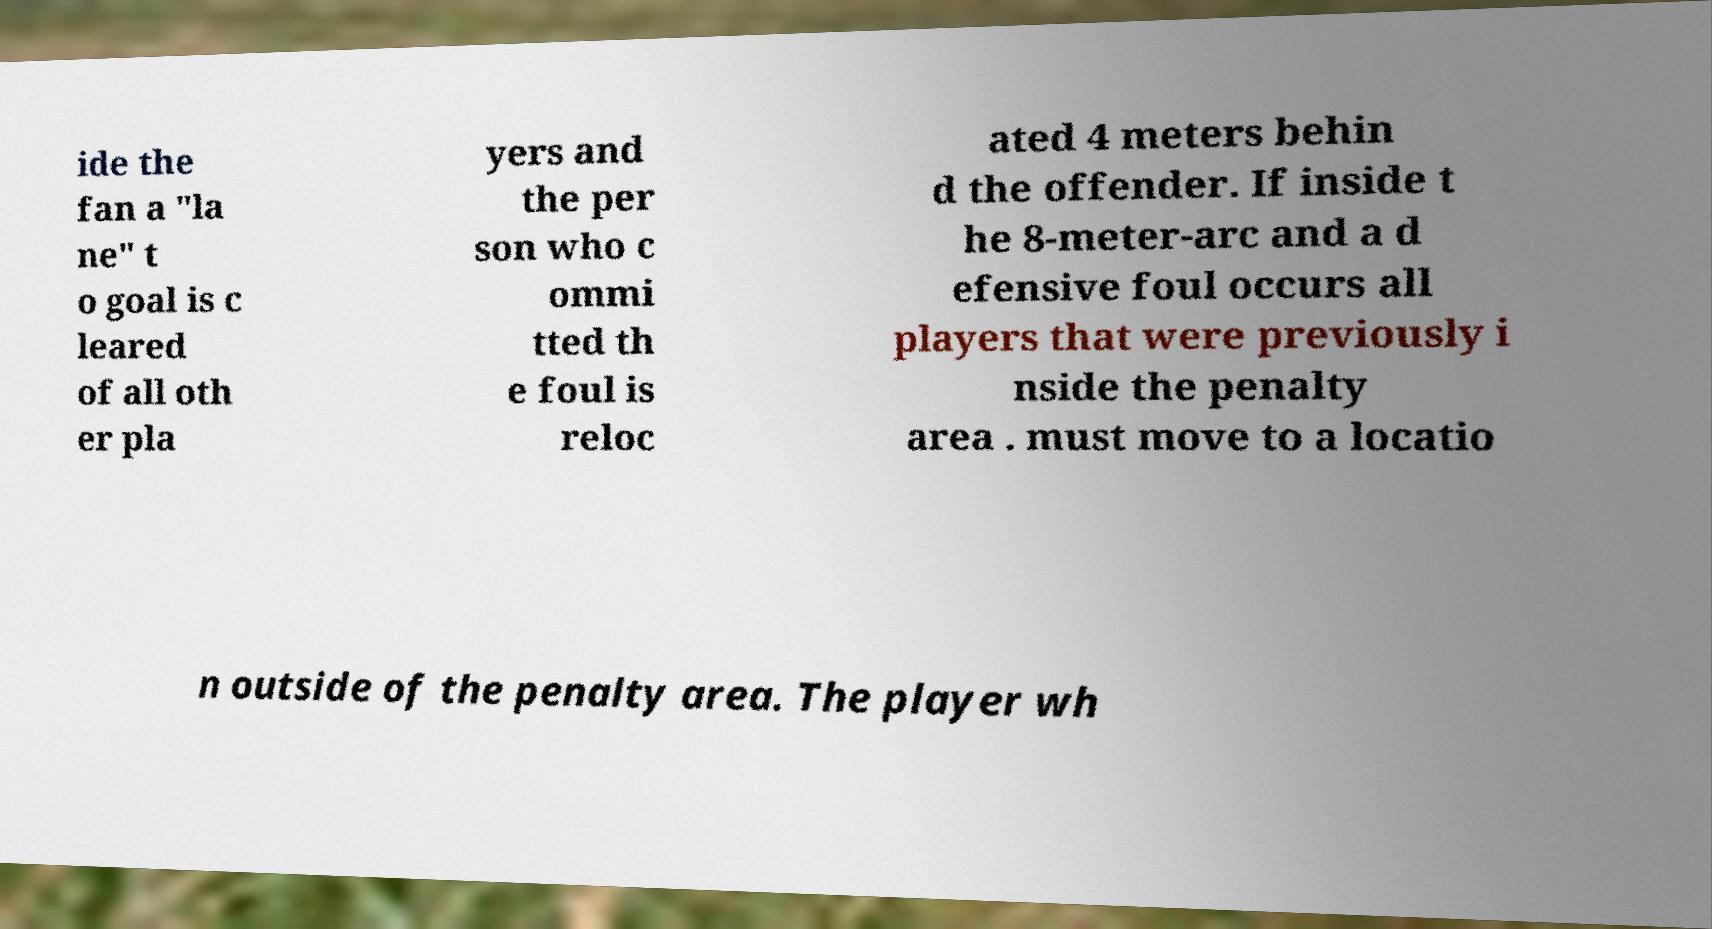Can you read and provide the text displayed in the image?This photo seems to have some interesting text. Can you extract and type it out for me? ide the fan a "la ne" t o goal is c leared of all oth er pla yers and the per son who c ommi tted th e foul is reloc ated 4 meters behin d the offender. If inside t he 8-meter-arc and a d efensive foul occurs all players that were previously i nside the penalty area . must move to a locatio n outside of the penalty area. The player wh 